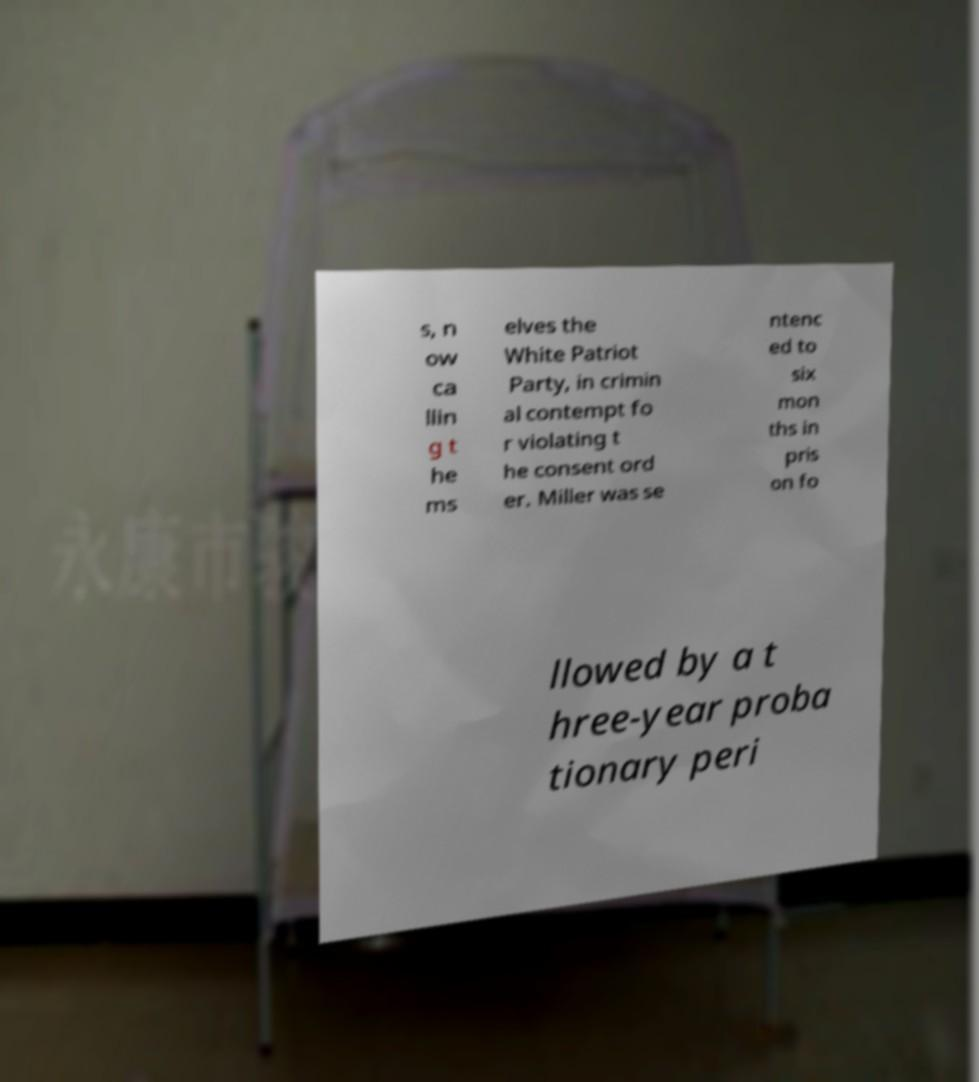I need the written content from this picture converted into text. Can you do that? s, n ow ca llin g t he ms elves the White Patriot Party, in crimin al contempt fo r violating t he consent ord er. Miller was se ntenc ed to six mon ths in pris on fo llowed by a t hree-year proba tionary peri 